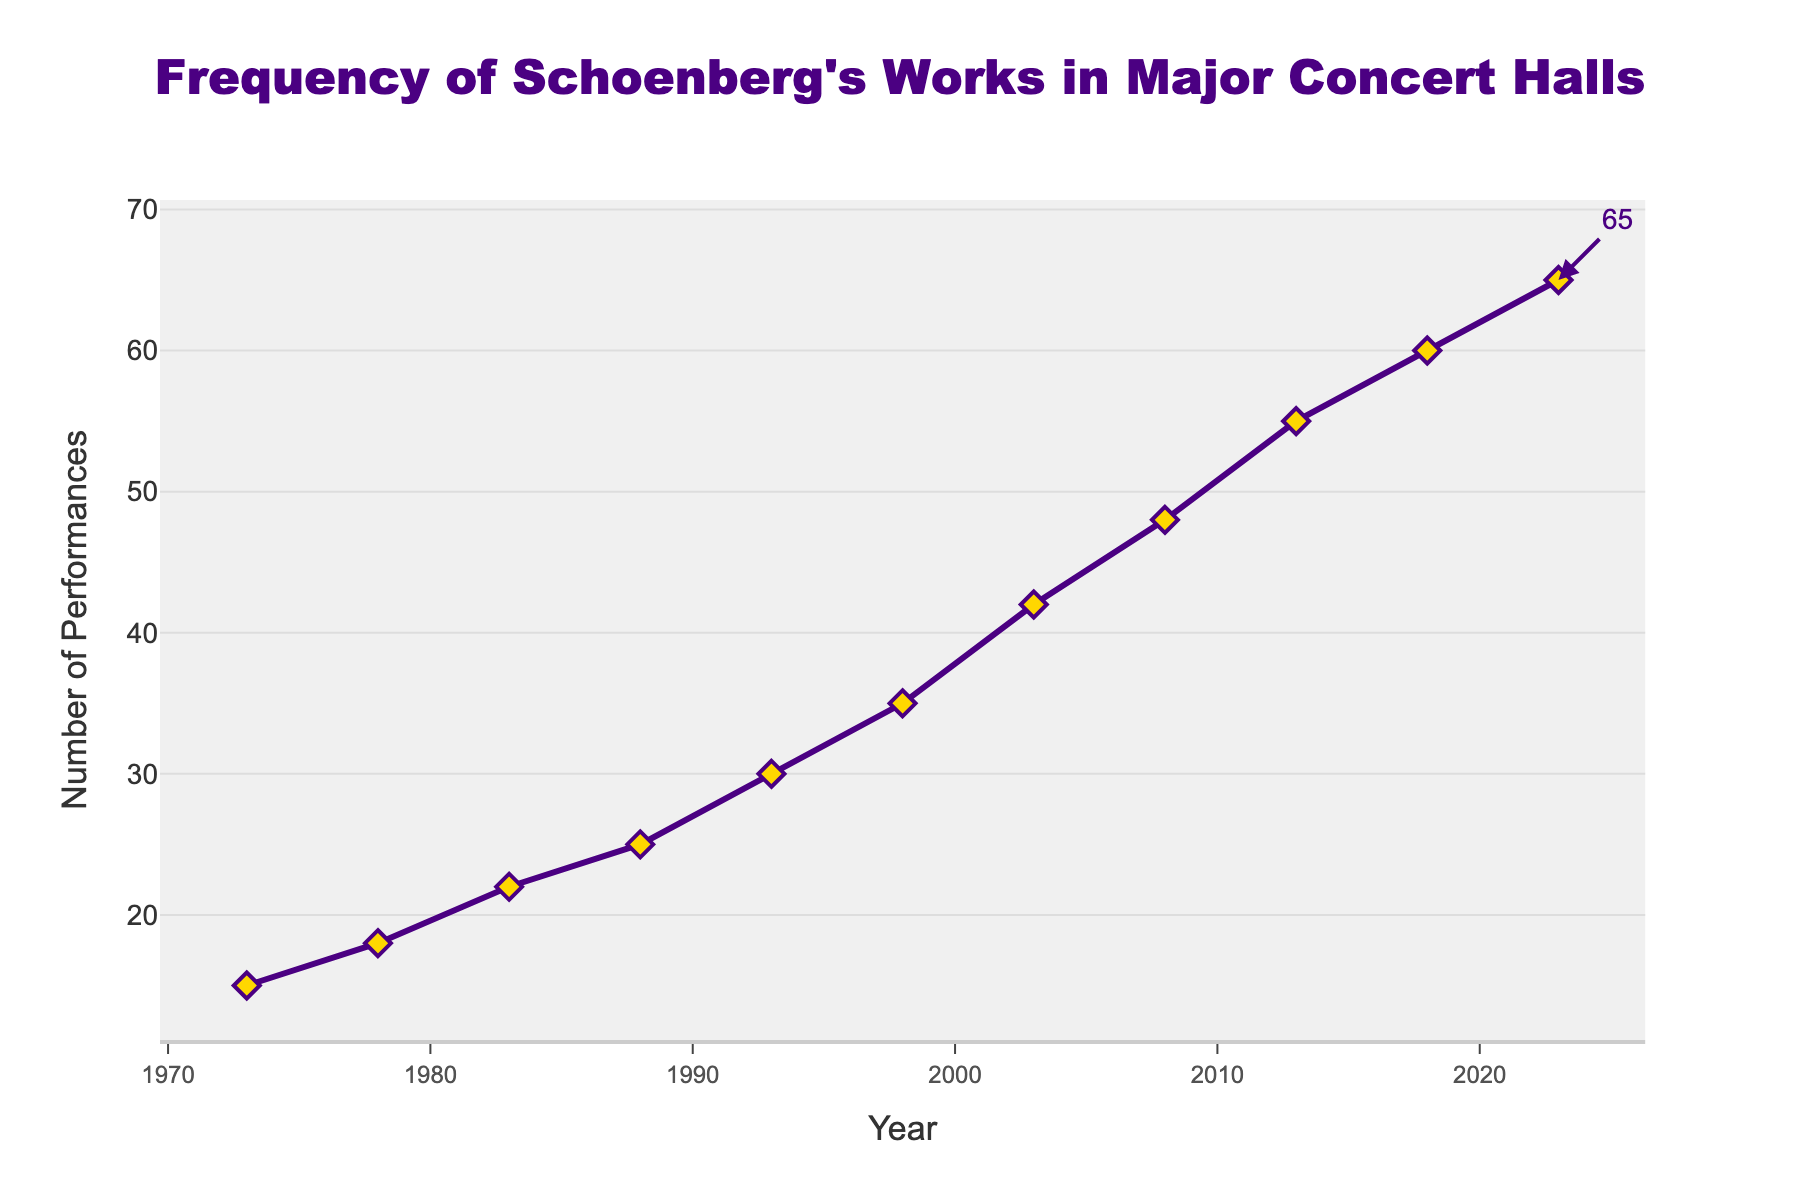what is the overall trend of performances of Schoenberg's works over the past 50 years? The graph shows an increase in the number of performances of Schoenberg's works from 1973 to 2023. The line is consistently rising without any significant drops, which indicates a steady growth in performances.
Answer: Increasing trend what was the number of performances in 2003 compared to 1998? In 1998, there were 35 performances, while in 2003 there were 42 performances. This shows an increase of 7 performances.
Answer: 7 more in 2003 how many performances were added from 1993 to 2013? In 1993, there were 30 performances and in 2013, there were 55 performances. The difference is 55 - 30 = 25
Answer: 25 which year saw the highest number of performances, and what was the number? The year 2023 saw the highest number of performances with a count of 65 performances.
Answer: 2023, 65 between which years was the growth in performances the most significant? The largest increase appears to be between 2003 and 2008, where performances rose from 42 to 48, a growth of 6 performances. However, if comparing the periods in larger intervals, between 2003 and 2013, there was a growth from 42 to 55, which is 13 performances.
Answer: 2003 to 2013 (+13 performances) what is the average rate of increase in performances per decade? From 1973 to 2023, which is a span of 50 years, the number of performances increased from 15 to 65. The total increase is 65 - 15 = 50. Over 5 decades, the average increase per decade is 50/5 = 10.
Answer: 10 performances per decade did the frequency of performances ever decrease over the years? Based on the visual trend in the chart, the number of performances increased steadily over each recorded period without any visible decrease.
Answer: No how did the number of performances change from 1978 to 1983? In 1978, there were 18 performances and in 1983, there were 22 performances. This is an increase of 4 performances.
Answer: increased by 4 